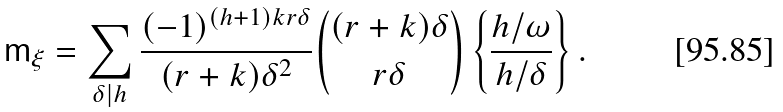Convert formula to latex. <formula><loc_0><loc_0><loc_500><loc_500>\mathsf m _ { \xi } = \sum _ { \delta | h } \frac { ( - 1 ) ^ { ( h + 1 ) k r \delta } } { ( r + k ) \delta ^ { 2 } } \binom { ( r + k ) \delta } { r \delta } \left \{ \frac { h / \omega } { h / \delta } \right \} .</formula> 